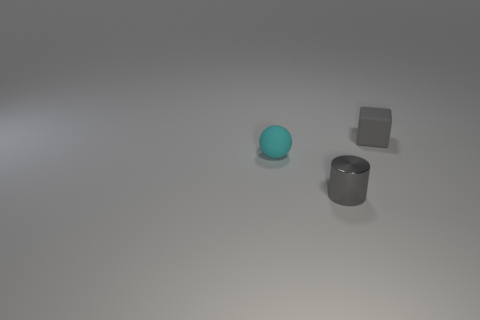How big is the gray matte block behind the sphere?
Provide a short and direct response. Small. Do the cyan ball and the gray thing that is in front of the small cyan rubber sphere have the same size?
Ensure brevity in your answer.  Yes. Is the number of small cyan rubber spheres that are to the left of the small ball less than the number of gray blocks?
Your answer should be compact. Yes. There is a object that is to the right of the sphere and behind the tiny gray shiny thing; what is its shape?
Ensure brevity in your answer.  Cube. What is the shape of the tiny cyan object that is made of the same material as the cube?
Make the answer very short. Sphere. What is the tiny object that is in front of the rubber ball made of?
Make the answer very short. Metal. There is a matte object left of the gray cube; is its size the same as the gray thing that is in front of the gray rubber object?
Ensure brevity in your answer.  Yes. The small ball is what color?
Make the answer very short. Cyan. There is a gray object that is on the right side of the small gray shiny cylinder; is its shape the same as the small cyan matte thing?
Offer a terse response. No. What material is the small cyan object?
Your response must be concise. Rubber. 